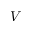Convert formula to latex. <formula><loc_0><loc_0><loc_500><loc_500>V</formula> 